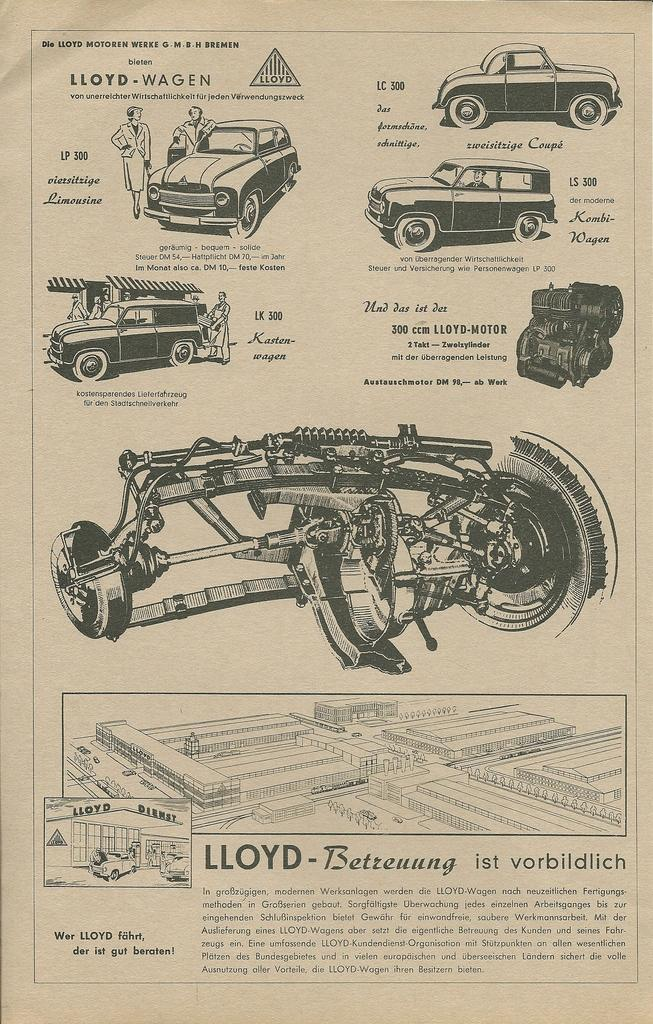What is the main subject of the image? The main subject of the image is a page. What can be found on the page? The page includes different parts of a car. What type of calendar is displayed on the page? There is no calendar present on the page; it only includes different parts of a car. 